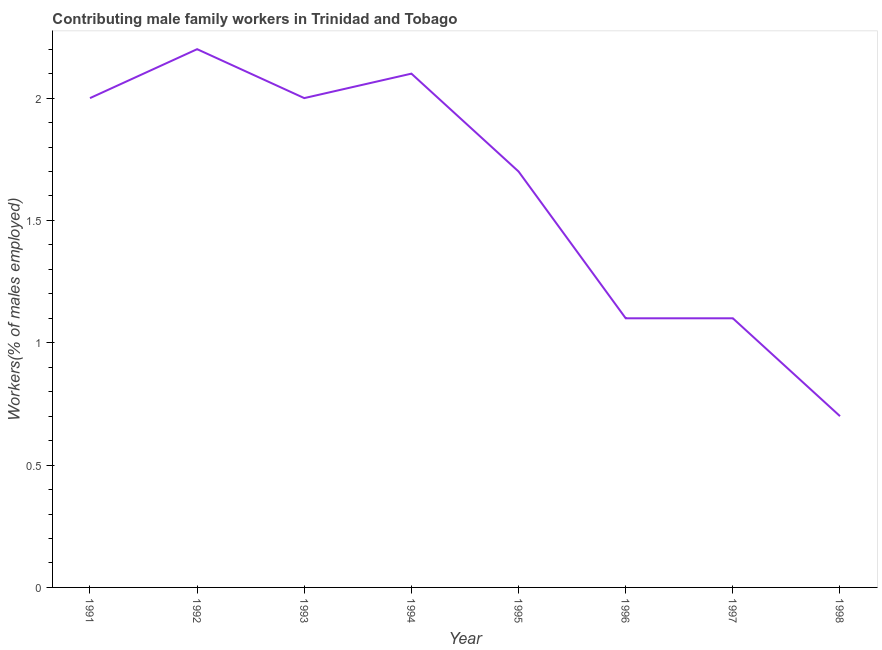What is the contributing male family workers in 1998?
Your response must be concise. 0.7. Across all years, what is the maximum contributing male family workers?
Give a very brief answer. 2.2. Across all years, what is the minimum contributing male family workers?
Give a very brief answer. 0.7. In which year was the contributing male family workers maximum?
Make the answer very short. 1992. In which year was the contributing male family workers minimum?
Offer a very short reply. 1998. What is the sum of the contributing male family workers?
Offer a very short reply. 12.9. What is the difference between the contributing male family workers in 1992 and 1995?
Provide a succinct answer. 0.5. What is the average contributing male family workers per year?
Keep it short and to the point. 1.61. What is the median contributing male family workers?
Offer a very short reply. 1.85. In how many years, is the contributing male family workers greater than 1.5 %?
Make the answer very short. 5. What is the ratio of the contributing male family workers in 1991 to that in 1992?
Your answer should be compact. 0.91. Is the difference between the contributing male family workers in 1991 and 1993 greater than the difference between any two years?
Your answer should be very brief. No. What is the difference between the highest and the second highest contributing male family workers?
Your answer should be very brief. 0.1. Is the sum of the contributing male family workers in 1994 and 1997 greater than the maximum contributing male family workers across all years?
Ensure brevity in your answer.  Yes. What is the difference between the highest and the lowest contributing male family workers?
Your response must be concise. 1.5. In how many years, is the contributing male family workers greater than the average contributing male family workers taken over all years?
Ensure brevity in your answer.  5. How many lines are there?
Make the answer very short. 1. What is the difference between two consecutive major ticks on the Y-axis?
Offer a very short reply. 0.5. Does the graph contain any zero values?
Ensure brevity in your answer.  No. Does the graph contain grids?
Your answer should be compact. No. What is the title of the graph?
Give a very brief answer. Contributing male family workers in Trinidad and Tobago. What is the label or title of the Y-axis?
Keep it short and to the point. Workers(% of males employed). What is the Workers(% of males employed) of 1991?
Your response must be concise. 2. What is the Workers(% of males employed) of 1992?
Offer a very short reply. 2.2. What is the Workers(% of males employed) in 1993?
Ensure brevity in your answer.  2. What is the Workers(% of males employed) of 1994?
Keep it short and to the point. 2.1. What is the Workers(% of males employed) of 1995?
Provide a succinct answer. 1.7. What is the Workers(% of males employed) in 1996?
Give a very brief answer. 1.1. What is the Workers(% of males employed) of 1997?
Offer a very short reply. 1.1. What is the Workers(% of males employed) in 1998?
Offer a terse response. 0.7. What is the difference between the Workers(% of males employed) in 1991 and 1992?
Ensure brevity in your answer.  -0.2. What is the difference between the Workers(% of males employed) in 1991 and 1993?
Keep it short and to the point. 0. What is the difference between the Workers(% of males employed) in 1991 and 1994?
Keep it short and to the point. -0.1. What is the difference between the Workers(% of males employed) in 1991 and 1996?
Your answer should be very brief. 0.9. What is the difference between the Workers(% of males employed) in 1991 and 1997?
Your answer should be compact. 0.9. What is the difference between the Workers(% of males employed) in 1991 and 1998?
Offer a very short reply. 1.3. What is the difference between the Workers(% of males employed) in 1992 and 1993?
Provide a short and direct response. 0.2. What is the difference between the Workers(% of males employed) in 1992 and 1994?
Give a very brief answer. 0.1. What is the difference between the Workers(% of males employed) in 1992 and 1996?
Provide a succinct answer. 1.1. What is the difference between the Workers(% of males employed) in 1992 and 1998?
Offer a terse response. 1.5. What is the difference between the Workers(% of males employed) in 1993 and 1994?
Ensure brevity in your answer.  -0.1. What is the difference between the Workers(% of males employed) in 1993 and 1996?
Make the answer very short. 0.9. What is the difference between the Workers(% of males employed) in 1993 and 1997?
Your answer should be very brief. 0.9. What is the difference between the Workers(% of males employed) in 1993 and 1998?
Give a very brief answer. 1.3. What is the difference between the Workers(% of males employed) in 1994 and 1996?
Offer a terse response. 1. What is the difference between the Workers(% of males employed) in 1995 and 1997?
Your answer should be very brief. 0.6. What is the difference between the Workers(% of males employed) in 1995 and 1998?
Make the answer very short. 1. What is the difference between the Workers(% of males employed) in 1996 and 1997?
Give a very brief answer. 0. What is the difference between the Workers(% of males employed) in 1997 and 1998?
Give a very brief answer. 0.4. What is the ratio of the Workers(% of males employed) in 1991 to that in 1992?
Give a very brief answer. 0.91. What is the ratio of the Workers(% of males employed) in 1991 to that in 1993?
Provide a succinct answer. 1. What is the ratio of the Workers(% of males employed) in 1991 to that in 1995?
Provide a succinct answer. 1.18. What is the ratio of the Workers(% of males employed) in 1991 to that in 1996?
Ensure brevity in your answer.  1.82. What is the ratio of the Workers(% of males employed) in 1991 to that in 1997?
Your response must be concise. 1.82. What is the ratio of the Workers(% of males employed) in 1991 to that in 1998?
Keep it short and to the point. 2.86. What is the ratio of the Workers(% of males employed) in 1992 to that in 1994?
Your answer should be compact. 1.05. What is the ratio of the Workers(% of males employed) in 1992 to that in 1995?
Your answer should be compact. 1.29. What is the ratio of the Workers(% of males employed) in 1992 to that in 1996?
Make the answer very short. 2. What is the ratio of the Workers(% of males employed) in 1992 to that in 1998?
Your response must be concise. 3.14. What is the ratio of the Workers(% of males employed) in 1993 to that in 1995?
Provide a short and direct response. 1.18. What is the ratio of the Workers(% of males employed) in 1993 to that in 1996?
Make the answer very short. 1.82. What is the ratio of the Workers(% of males employed) in 1993 to that in 1997?
Provide a succinct answer. 1.82. What is the ratio of the Workers(% of males employed) in 1993 to that in 1998?
Provide a short and direct response. 2.86. What is the ratio of the Workers(% of males employed) in 1994 to that in 1995?
Offer a very short reply. 1.24. What is the ratio of the Workers(% of males employed) in 1994 to that in 1996?
Provide a succinct answer. 1.91. What is the ratio of the Workers(% of males employed) in 1994 to that in 1997?
Your response must be concise. 1.91. What is the ratio of the Workers(% of males employed) in 1995 to that in 1996?
Your answer should be compact. 1.54. What is the ratio of the Workers(% of males employed) in 1995 to that in 1997?
Give a very brief answer. 1.54. What is the ratio of the Workers(% of males employed) in 1995 to that in 1998?
Your answer should be compact. 2.43. What is the ratio of the Workers(% of males employed) in 1996 to that in 1997?
Your answer should be very brief. 1. What is the ratio of the Workers(% of males employed) in 1996 to that in 1998?
Your answer should be very brief. 1.57. What is the ratio of the Workers(% of males employed) in 1997 to that in 1998?
Keep it short and to the point. 1.57. 